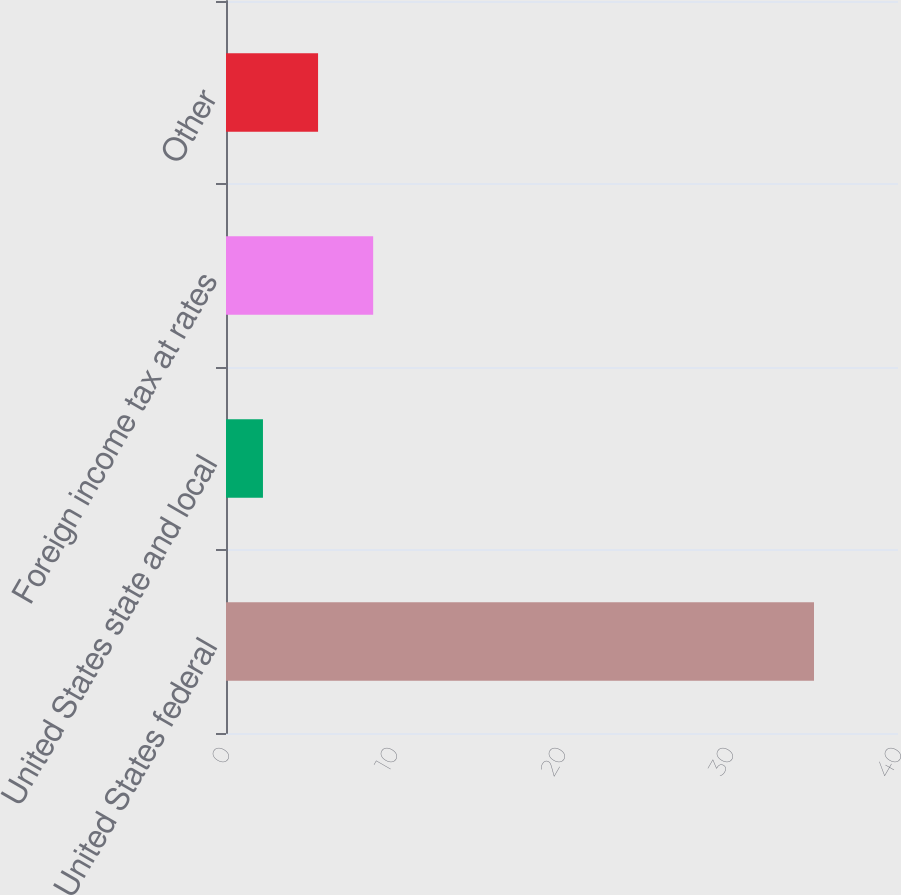<chart> <loc_0><loc_0><loc_500><loc_500><bar_chart><fcel>United States federal<fcel>United States state and local<fcel>Foreign income tax at rates<fcel>Other<nl><fcel>35<fcel>2.2<fcel>8.76<fcel>5.48<nl></chart> 